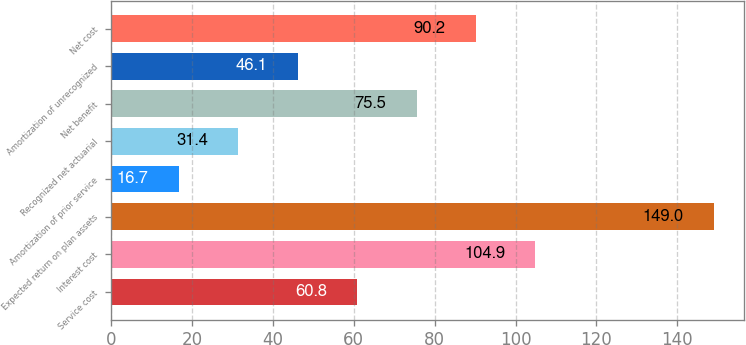Convert chart to OTSL. <chart><loc_0><loc_0><loc_500><loc_500><bar_chart><fcel>Service cost<fcel>Interest cost<fcel>Expected return on plan assets<fcel>Amortization of prior service<fcel>Recognized net actuarial<fcel>Net benefit<fcel>Amortization of unrecognized<fcel>Net cost<nl><fcel>60.8<fcel>104.9<fcel>149<fcel>16.7<fcel>31.4<fcel>75.5<fcel>46.1<fcel>90.2<nl></chart> 